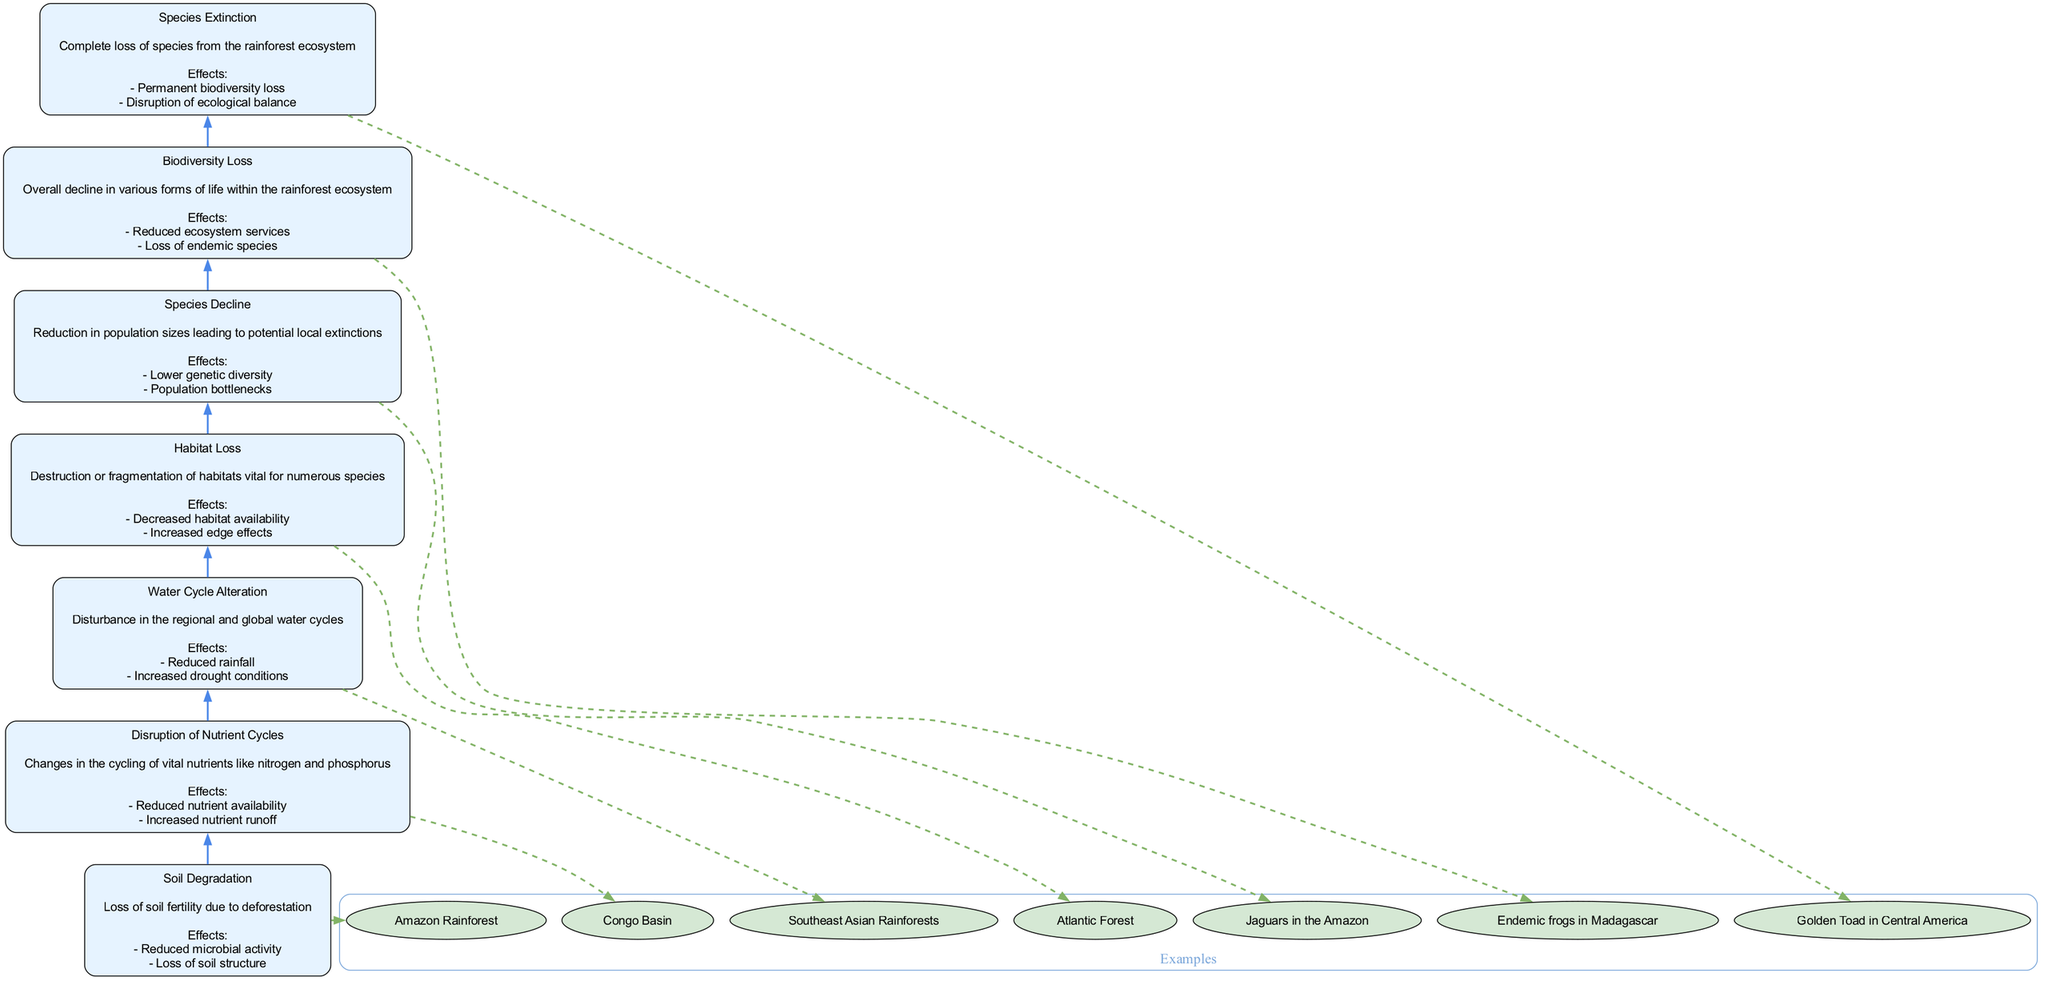What is the top node in the diagram? The top node represents the end state of the flow chart, which in this case is "Species Extinction". This is deduced by tracing the flow from the bottom to the top of the diagram, where each node leads to the next until reaching the top.
Answer: Species Extinction How many nodes are present in the diagram? By counting each distinct element listed in the data, we find there are 7 nodes, which are each labeled with key processes or consequences of deforestation.
Answer: 7 What is the effect mentioned under "Habitat Loss"? The diagram provides details under each node, and for "Habitat Loss", one of the effects listed is "Decreased habitat availability". This is directly referenced in the effects part of the node description.
Answer: Decreased habitat availability What precedes "Biodiversity Loss" in the flow? The flow chart illustrates a sequence where "Species Decline" leads directly to "Biodiversity Loss," as each node flows upward, indicating that species decline is a precursor to biodiversity loss.
Answer: Species Decline What is the relationship between "Water Cycle Alteration" and "Disruption of Nutrient Cycles"? The flow chart shows that "Water Cycle Alteration" is positioned above "Disruption of Nutrient Cycles", indicating a direct flow relationship where the alteration of the water cycle may influence the cycling of nutrients, although they are separate issues.
Answer: Direct flow relationship What is one example provided for "Soil Degradation"? Each node in the diagram includes examples, and for "Soil Degradation," the provided example is "Amazon Rainforest". This information is specifically noted as an instance where soil degradation occurs.
Answer: Amazon Rainforest What is the resulting effect of "Species Extinction"? The final node describes the consequences of species extinction, which includes "Permanent biodiversity loss". This reflects the irreversible impact of extinction on biodiversity.
Answer: Permanent biodiversity loss Which node describes a change in nitrogen and phosphorus cycling? The node titled "Disruption of Nutrient Cycles" directly addresses changes in the cycling of nitrogen and phosphorus, as outlined in its description. This designation allows us to identify its specific focus.
Answer: Disruption of Nutrient Cycles 